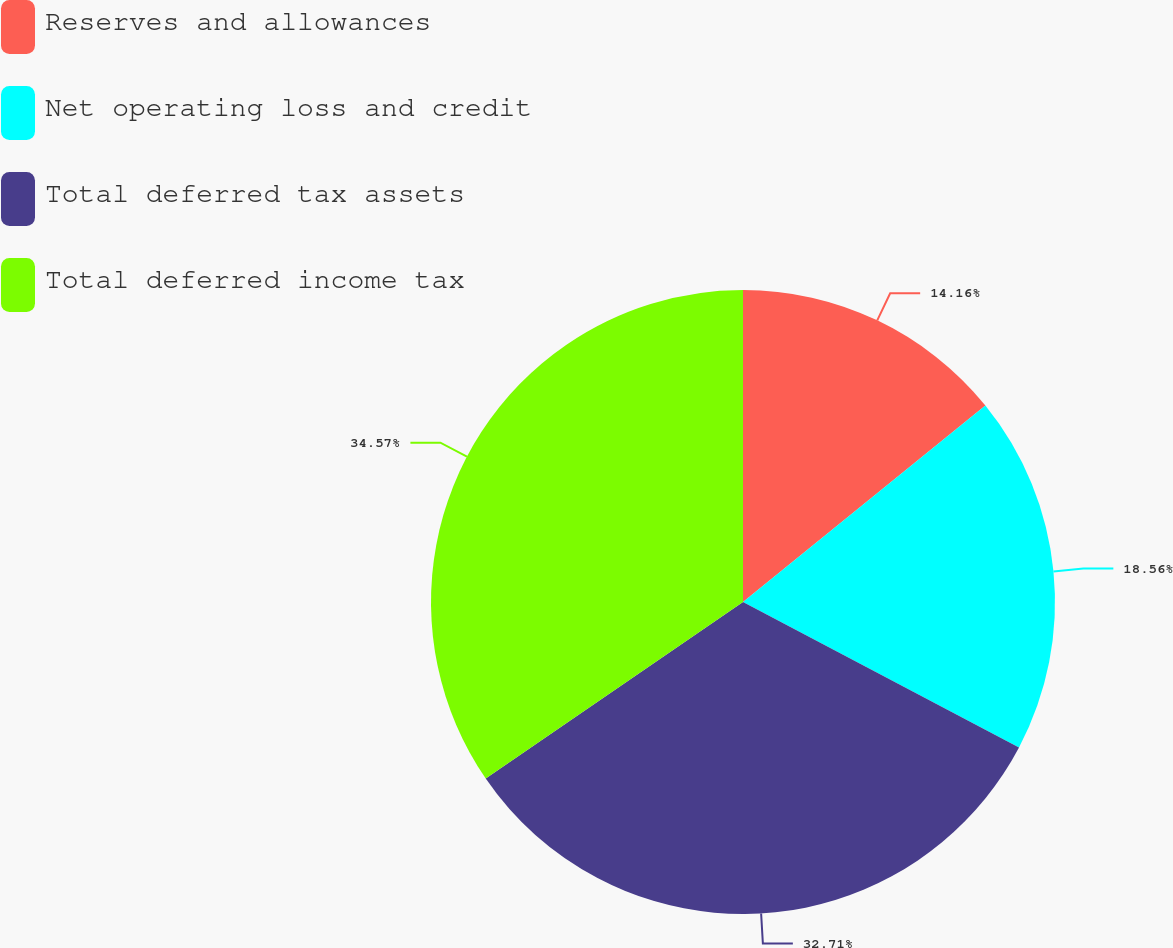<chart> <loc_0><loc_0><loc_500><loc_500><pie_chart><fcel>Reserves and allowances<fcel>Net operating loss and credit<fcel>Total deferred tax assets<fcel>Total deferred income tax<nl><fcel>14.16%<fcel>18.56%<fcel>32.71%<fcel>34.57%<nl></chart> 